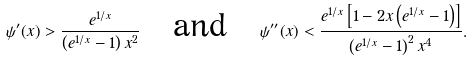Convert formula to latex. <formula><loc_0><loc_0><loc_500><loc_500>\psi ^ { \prime } ( x ) > \frac { e ^ { 1 / x } } { \left ( e ^ { 1 / x } - 1 \right ) x ^ { 2 } } \quad \text {and} \quad \psi ^ { \prime \prime } ( x ) < \frac { e ^ { 1 / x } \left [ 1 - 2 x \left ( e ^ { 1 / x } - 1 \right ) \right ] } { \left ( e ^ { 1 / x } - 1 \right ) ^ { 2 } x ^ { 4 } } .</formula> 